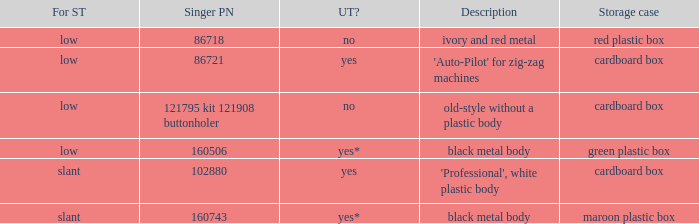What's the singer part number of the buttonholer whose storage case is a green plastic box? 160506.0. 